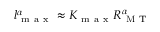<formula> <loc_0><loc_0><loc_500><loc_500>l _ { m a x } ^ { \alpha } \approx K _ { m a x } R _ { M T } ^ { \alpha }</formula> 